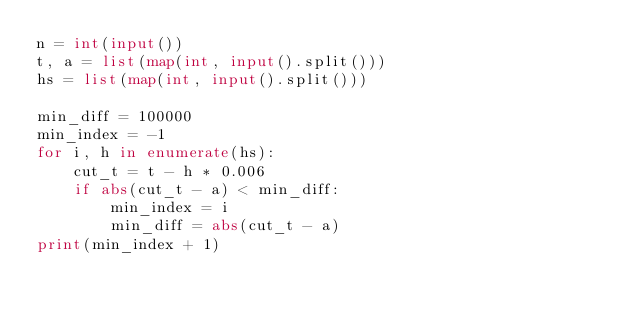<code> <loc_0><loc_0><loc_500><loc_500><_Python_>n = int(input())
t, a = list(map(int, input().split()))
hs = list(map(int, input().split()))

min_diff = 100000
min_index = -1
for i, h in enumerate(hs):
    cut_t = t - h * 0.006
    if abs(cut_t - a) < min_diff:
        min_index = i
        min_diff = abs(cut_t - a)
print(min_index + 1)
</code> 